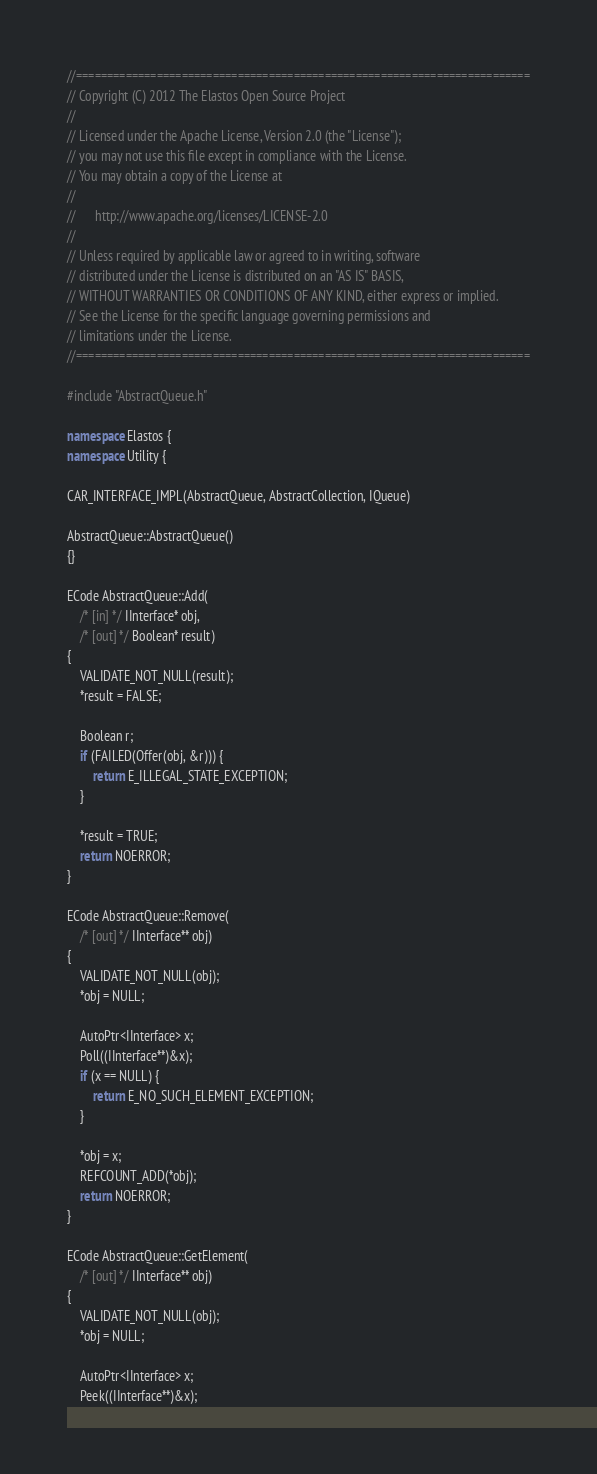<code> <loc_0><loc_0><loc_500><loc_500><_C++_>//=========================================================================
// Copyright (C) 2012 The Elastos Open Source Project
//
// Licensed under the Apache License, Version 2.0 (the "License");
// you may not use this file except in compliance with the License.
// You may obtain a copy of the License at
//
//      http://www.apache.org/licenses/LICENSE-2.0
//
// Unless required by applicable law or agreed to in writing, software
// distributed under the License is distributed on an "AS IS" BASIS,
// WITHOUT WARRANTIES OR CONDITIONS OF ANY KIND, either express or implied.
// See the License for the specific language governing permissions and
// limitations under the License.
//=========================================================================

#include "AbstractQueue.h"

namespace Elastos {
namespace Utility {

CAR_INTERFACE_IMPL(AbstractQueue, AbstractCollection, IQueue)

AbstractQueue::AbstractQueue()
{}

ECode AbstractQueue::Add(
    /* [in] */ IInterface* obj,
    /* [out] */ Boolean* result)
{
    VALIDATE_NOT_NULL(result);
    *result = FALSE;

    Boolean r;
    if (FAILED(Offer(obj, &r))) {
        return E_ILLEGAL_STATE_EXCEPTION;
    }

    *result = TRUE;
    return NOERROR;
}

ECode AbstractQueue::Remove(
    /* [out] */ IInterface** obj)
{
    VALIDATE_NOT_NULL(obj);
    *obj = NULL;

    AutoPtr<IInterface> x;
    Poll((IInterface**)&x);
    if (x == NULL) {
        return E_NO_SUCH_ELEMENT_EXCEPTION;
    }

    *obj = x;
    REFCOUNT_ADD(*obj);
    return NOERROR;
}

ECode AbstractQueue::GetElement(
    /* [out] */ IInterface** obj)
{
    VALIDATE_NOT_NULL(obj);
    *obj = NULL;

    AutoPtr<IInterface> x;
    Peek((IInterface**)&x);</code> 